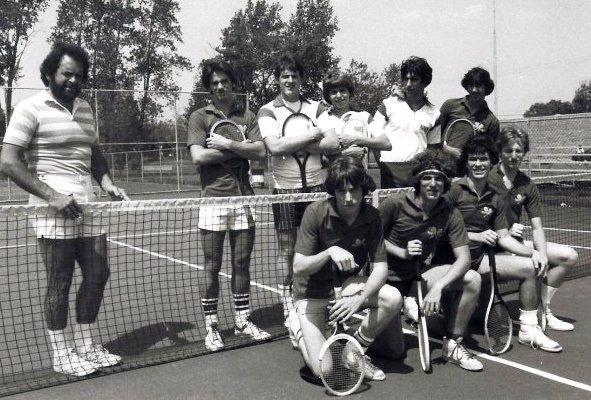How many people?
Give a very brief answer. 10. How many people can you see?
Give a very brief answer. 10. 